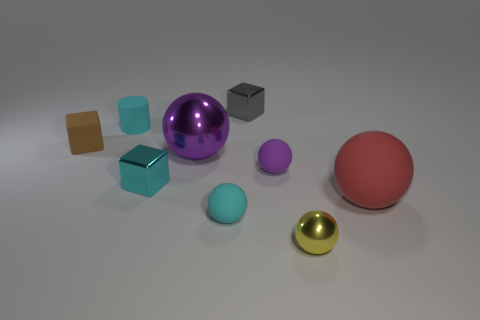What is the material of the cyan cube?
Your answer should be very brief. Metal. Is the color of the tiny metal thing behind the tiny cylinder the same as the small metal ball?
Provide a short and direct response. No. Is there anything else that is the same shape as the small purple matte thing?
Keep it short and to the point. Yes. There is another tiny shiny object that is the same shape as the cyan metallic object; what is its color?
Your answer should be compact. Gray. There is a big sphere that is on the right side of the gray object; what is its material?
Offer a very short reply. Rubber. What is the color of the tiny metal sphere?
Give a very brief answer. Yellow. Is the size of the rubber object to the right of the yellow ball the same as the brown object?
Ensure brevity in your answer.  No. What material is the large thing to the left of the big object that is in front of the large thing that is left of the tiny gray thing made of?
Give a very brief answer. Metal. There is a large thing that is in front of the cyan metal cube; is its color the same as the tiny thing that is to the left of the tiny cyan cylinder?
Your answer should be compact. No. What material is the big thing in front of the tiny metallic cube that is in front of the brown cube made of?
Your response must be concise. Rubber. 